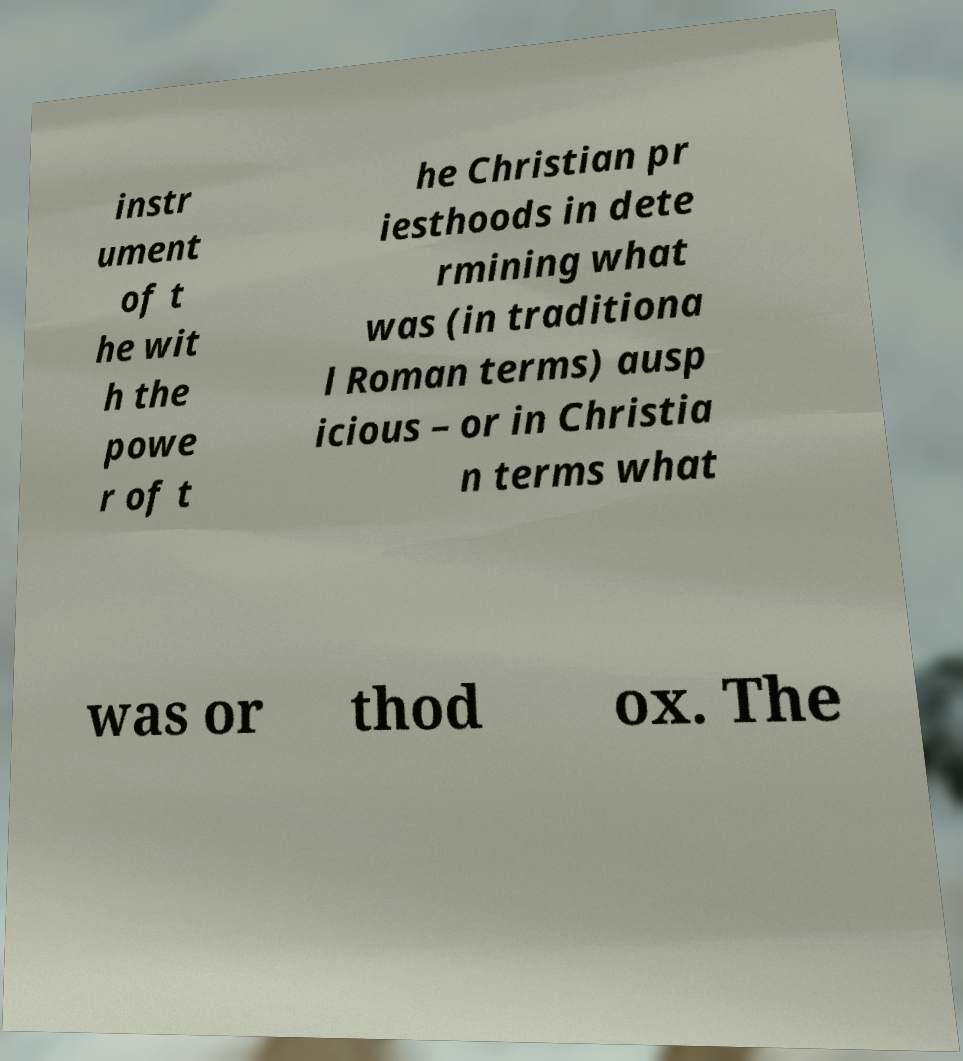Could you assist in decoding the text presented in this image and type it out clearly? instr ument of t he wit h the powe r of t he Christian pr iesthoods in dete rmining what was (in traditiona l Roman terms) ausp icious – or in Christia n terms what was or thod ox. The 